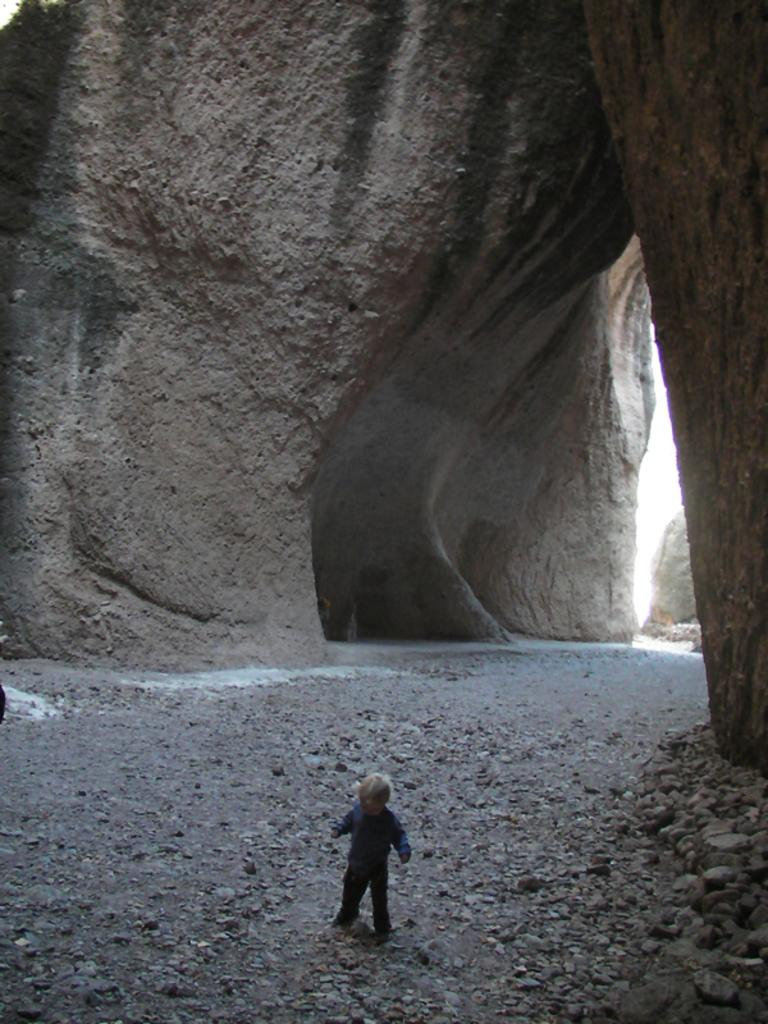What is the main subject of the image? The main subject of the image is a kid. What type of natural formation can be seen in the image? There is a rock hill in the image. What type of objects are present on the ground in the image? There are stones in the image. What is visible in the background of the image? The sky is visible in the image. What type of mine can be seen in the image? There is no mine present in the image. What type of oven is visible in the image? There is no oven present in the image. How many trucks are visible in the image? There are no trucks present in the image. 